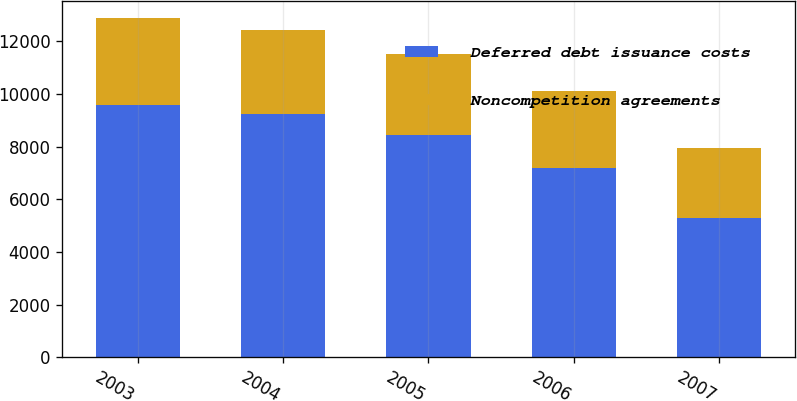Convert chart to OTSL. <chart><loc_0><loc_0><loc_500><loc_500><stacked_bar_chart><ecel><fcel>2003<fcel>2004<fcel>2005<fcel>2006<fcel>2007<nl><fcel>Deferred debt issuance costs<fcel>9589<fcel>9229<fcel>8457<fcel>7186<fcel>5280<nl><fcel>Noncompetition agreements<fcel>3321<fcel>3201<fcel>3080<fcel>2942<fcel>2682<nl></chart> 